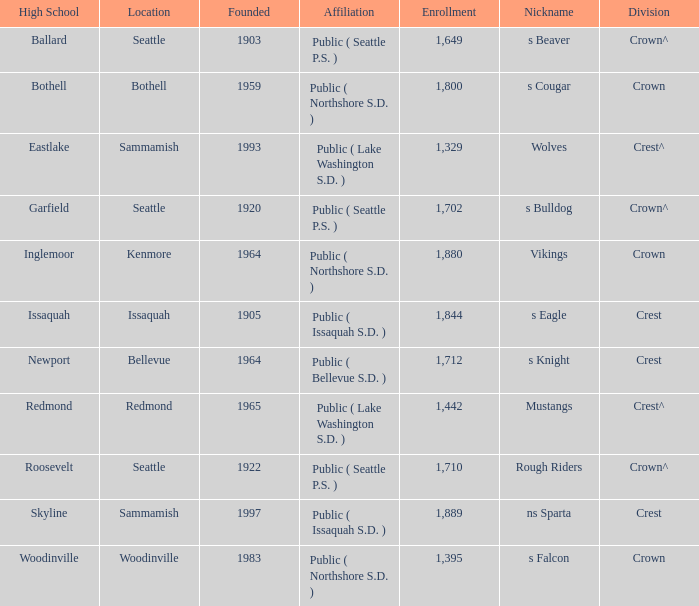What high school known as s eagle features a division of emblem? Issaquah. 